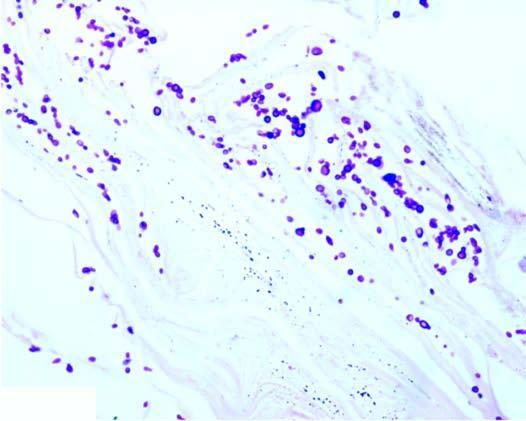what shows presence of numerous arthrospores and hyphae?
Answer the question using a single word or phrase. Stratum corneum around the hair follicle 